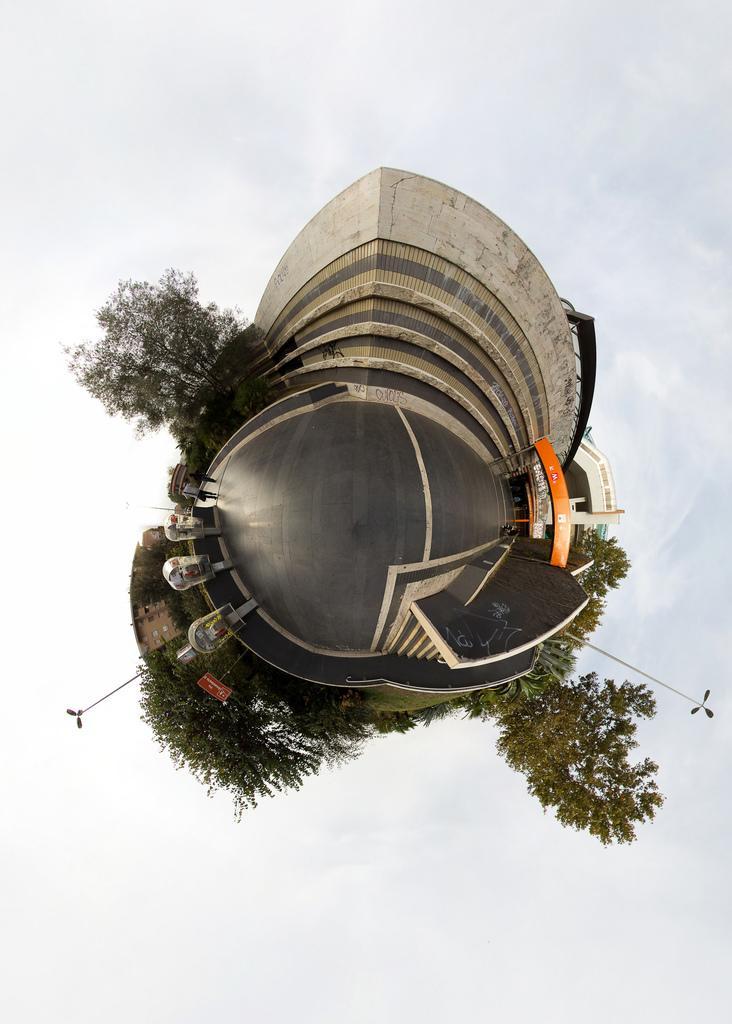In one or two sentences, can you explain what this image depicts? In this picture I can see in the middle it is an edited image, it looks like a building and there are trees. 